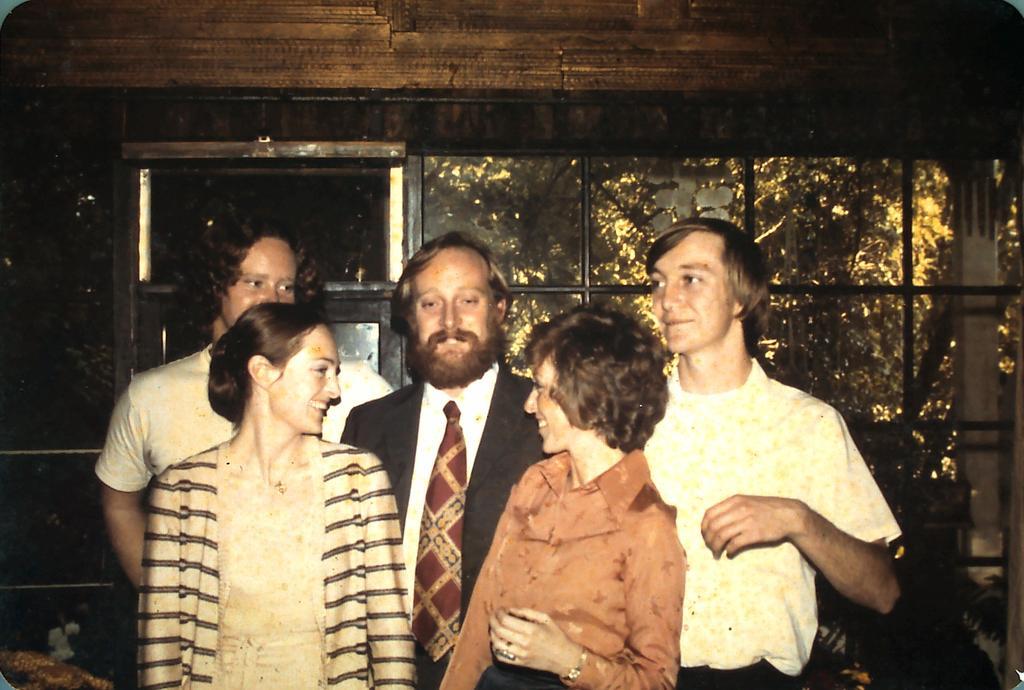Could you give a brief overview of what you see in this image? In the foreground of this image, there are two women and three men standing. In the background, it seems like a glass wall and a window. Through the glass, there are trees. 